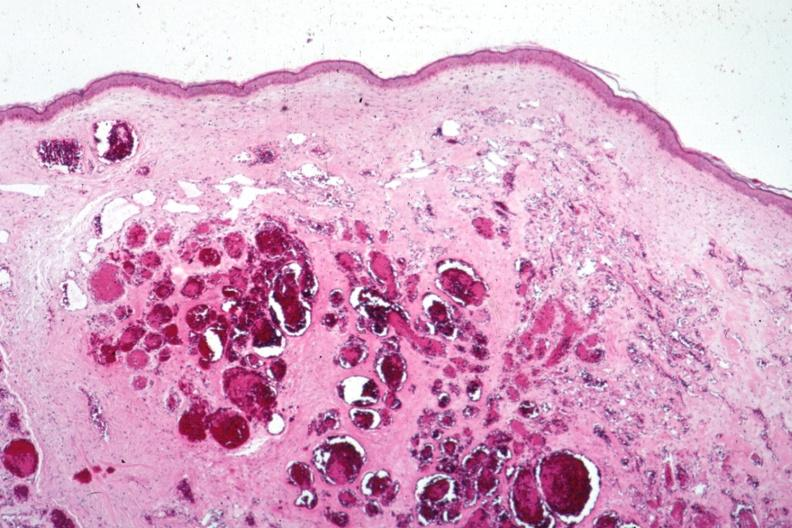does this image show typical cavernous lesion?
Answer the question using a single word or phrase. Yes 